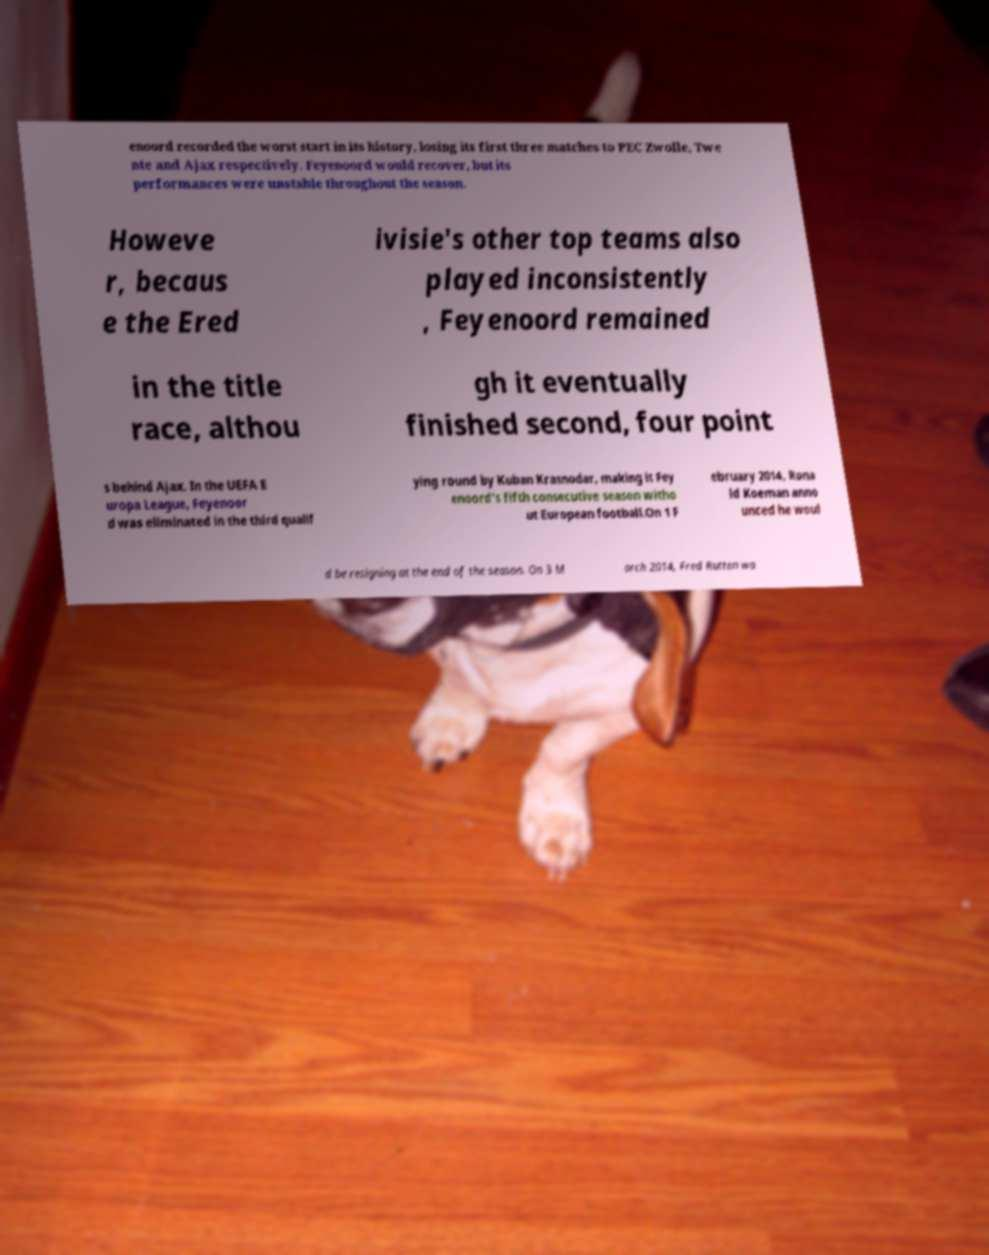What messages or text are displayed in this image? I need them in a readable, typed format. enoord recorded the worst start in its history, losing its first three matches to PEC Zwolle, Twe nte and Ajax respectively. Feyenoord would recover, but its performances were unstable throughout the season. Howeve r, becaus e the Ered ivisie's other top teams also played inconsistently , Feyenoord remained in the title race, althou gh it eventually finished second, four point s behind Ajax. In the UEFA E uropa League, Feyenoor d was eliminated in the third qualif ying round by Kuban Krasnodar, making it Fey enoord's fifth consecutive season witho ut European football.On 1 F ebruary 2014, Rona ld Koeman anno unced he woul d be resigning at the end of the season. On 3 M arch 2014, Fred Rutten wa 